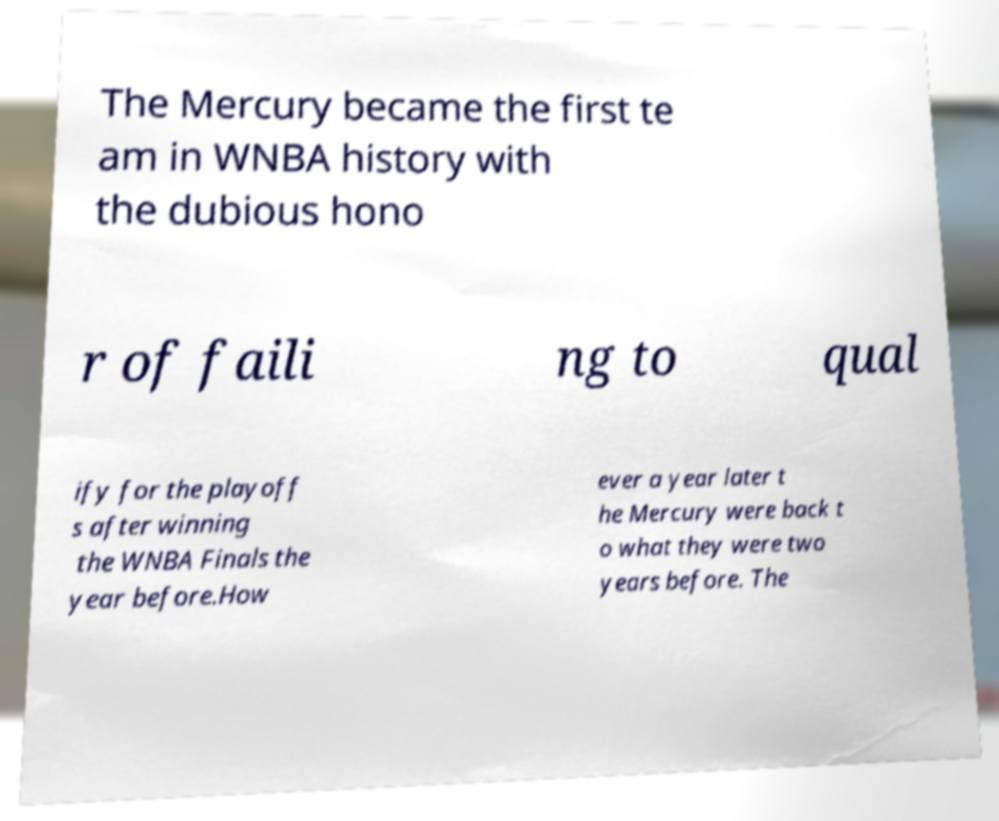Can you accurately transcribe the text from the provided image for me? The Mercury became the first te am in WNBA history with the dubious hono r of faili ng to qual ify for the playoff s after winning the WNBA Finals the year before.How ever a year later t he Mercury were back t o what they were two years before. The 